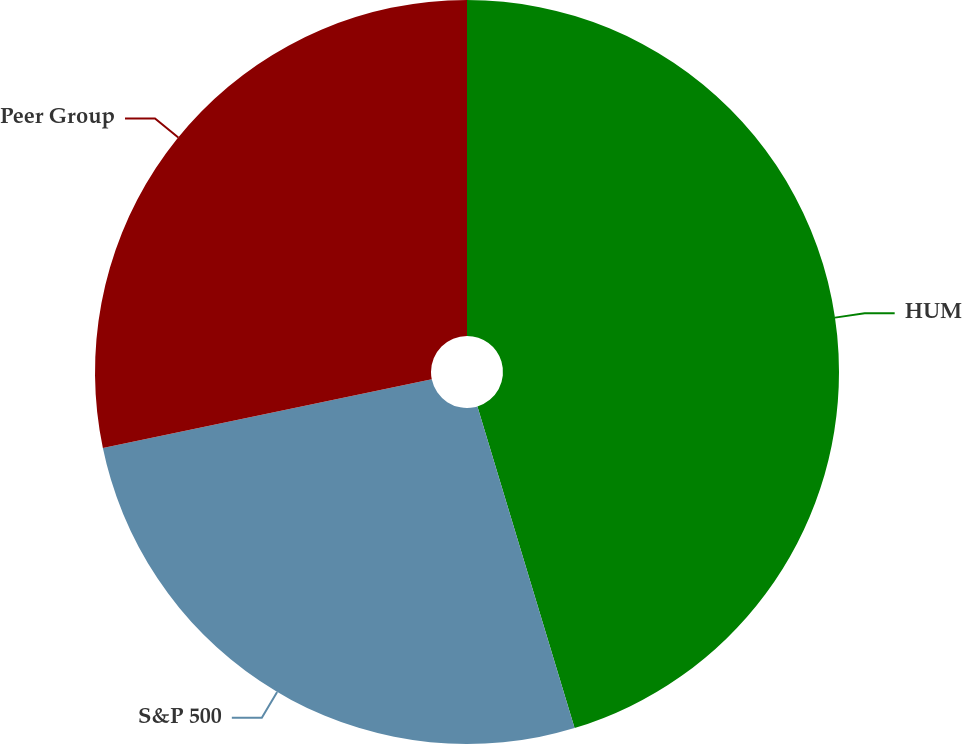Convert chart to OTSL. <chart><loc_0><loc_0><loc_500><loc_500><pie_chart><fcel>HUM<fcel>S&P 500<fcel>Peer Group<nl><fcel>45.33%<fcel>26.39%<fcel>28.28%<nl></chart> 